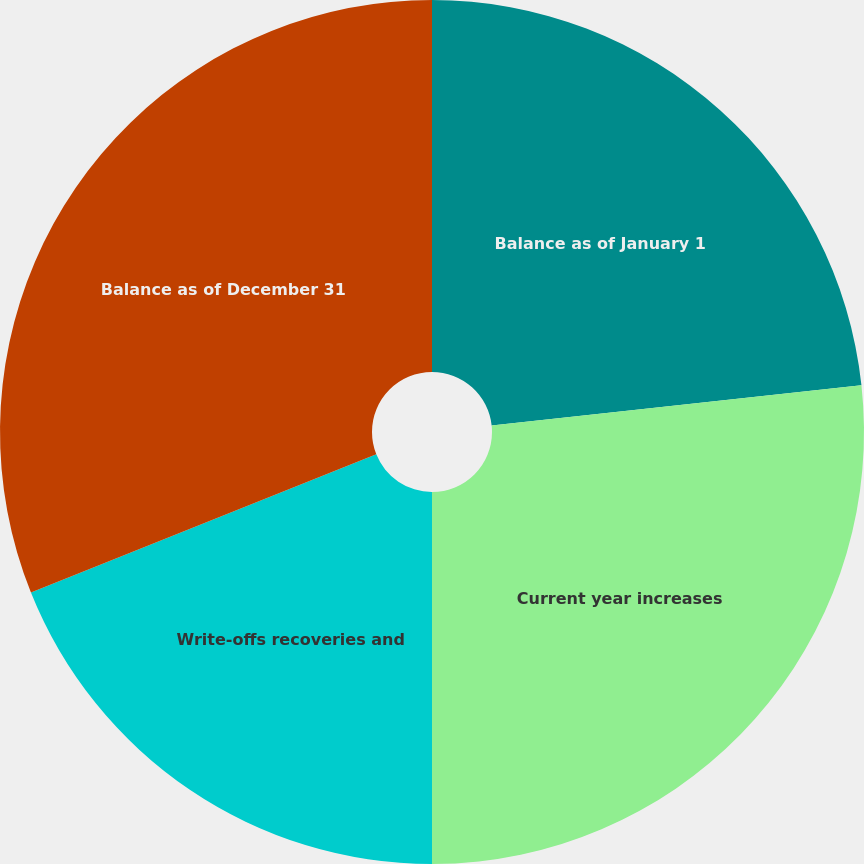<chart> <loc_0><loc_0><loc_500><loc_500><pie_chart><fcel>Balance as of January 1<fcel>Current year increases<fcel>Write-offs recoveries and<fcel>Balance as of December 31<nl><fcel>23.27%<fcel>26.73%<fcel>18.94%<fcel>31.06%<nl></chart> 